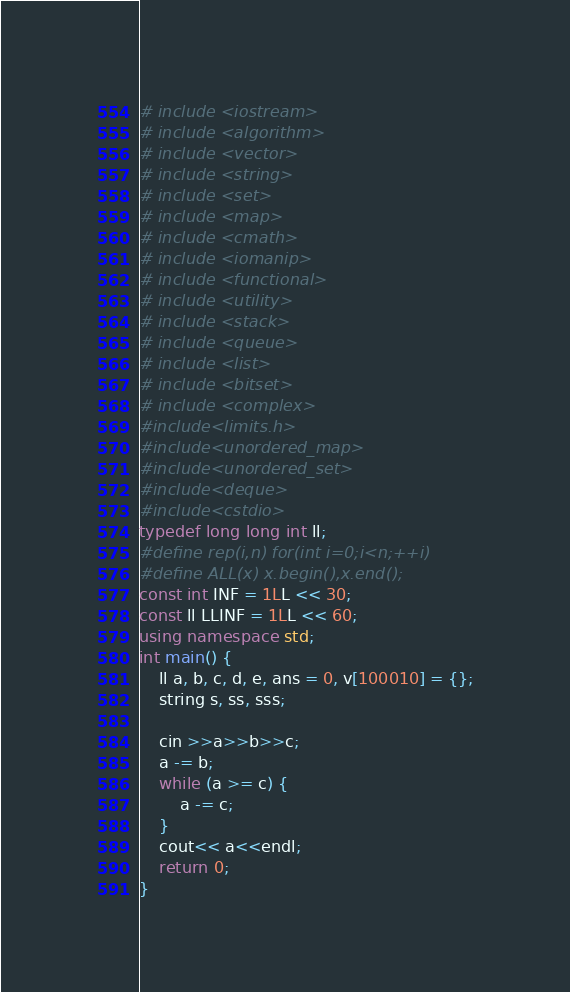Convert code to text. <code><loc_0><loc_0><loc_500><loc_500><_C++_># include <iostream>
# include <algorithm>
# include <vector>
# include <string>
# include <set>
# include <map>
# include <cmath>
# include <iomanip>
# include <functional>
# include <utility>
# include <stack>
# include <queue>
# include <list>
# include <bitset>
# include <complex>
#include<limits.h>
#include<unordered_map>
#include<unordered_set>
#include<deque>
#include<cstdio>
typedef long long int ll;
#define rep(i,n) for(int i=0;i<n;++i)
#define ALL(x) x.begin(),x.end();
const int INF = 1LL << 30;
const ll LLINF = 1LL << 60;
using namespace std;
int main() {
	ll a, b, c, d, e, ans = 0, v[100010] = {};
	string s, ss, sss;

	cin >>a>>b>>c;
	a -= b;
	while (a >= c) {
		a -= c;
	}
	cout<< a<<endl;
	return 0;
}</code> 